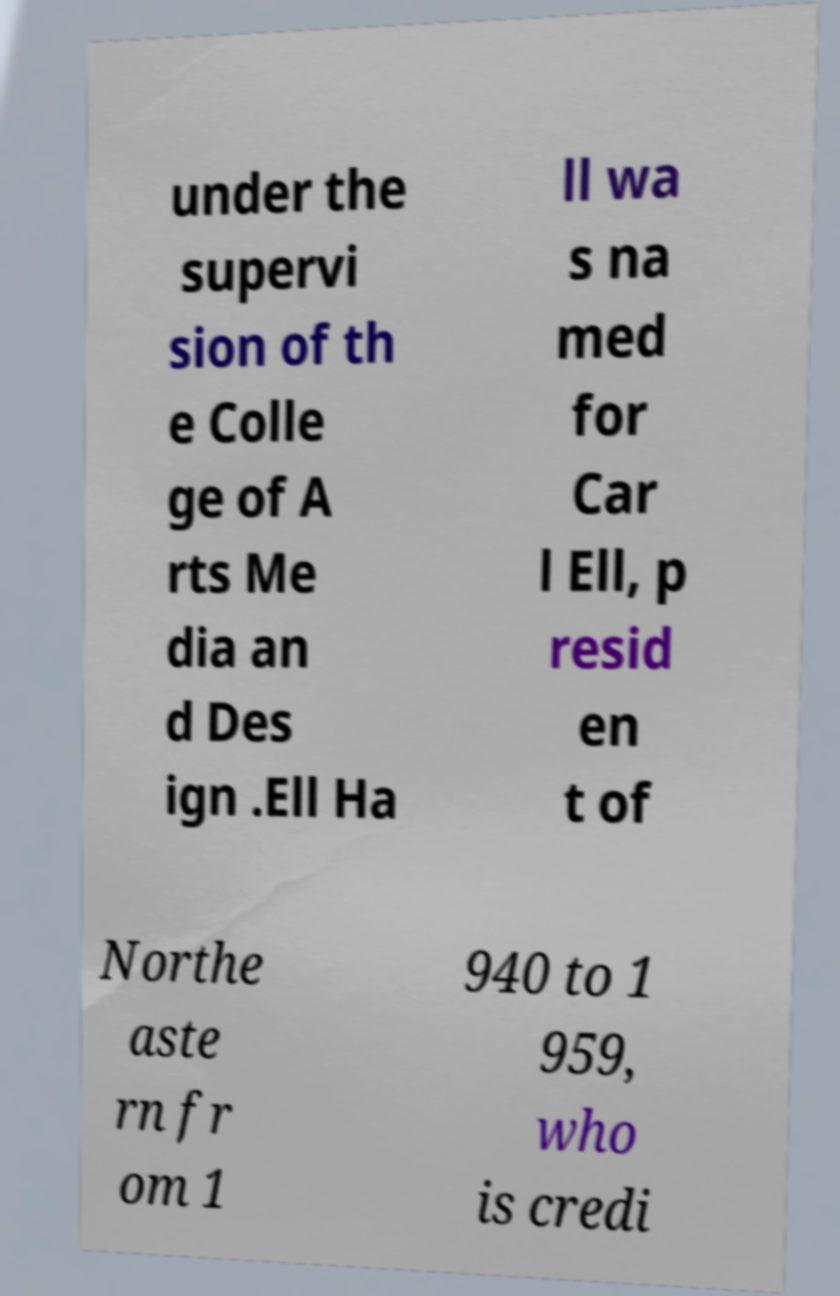There's text embedded in this image that I need extracted. Can you transcribe it verbatim? under the supervi sion of th e Colle ge of A rts Me dia an d Des ign .Ell Ha ll wa s na med for Car l Ell, p resid en t of Northe aste rn fr om 1 940 to 1 959, who is credi 